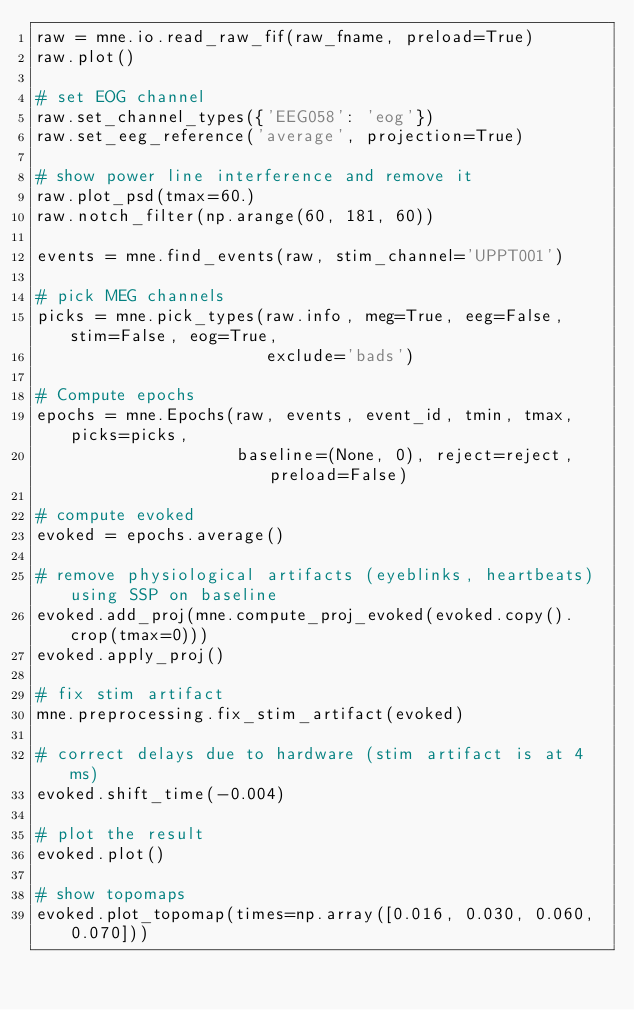Convert code to text. <code><loc_0><loc_0><loc_500><loc_500><_Python_>raw = mne.io.read_raw_fif(raw_fname, preload=True)
raw.plot()

# set EOG channel
raw.set_channel_types({'EEG058': 'eog'})
raw.set_eeg_reference('average', projection=True)

# show power line interference and remove it
raw.plot_psd(tmax=60.)
raw.notch_filter(np.arange(60, 181, 60))

events = mne.find_events(raw, stim_channel='UPPT001')

# pick MEG channels
picks = mne.pick_types(raw.info, meg=True, eeg=False, stim=False, eog=True,
                       exclude='bads')

# Compute epochs
epochs = mne.Epochs(raw, events, event_id, tmin, tmax, picks=picks,
                    baseline=(None, 0), reject=reject, preload=False)

# compute evoked
evoked = epochs.average()

# remove physiological artifacts (eyeblinks, heartbeats) using SSP on baseline
evoked.add_proj(mne.compute_proj_evoked(evoked.copy().crop(tmax=0)))
evoked.apply_proj()

# fix stim artifact
mne.preprocessing.fix_stim_artifact(evoked)

# correct delays due to hardware (stim artifact is at 4 ms)
evoked.shift_time(-0.004)

# plot the result
evoked.plot()

# show topomaps
evoked.plot_topomap(times=np.array([0.016, 0.030, 0.060, 0.070]))
</code> 